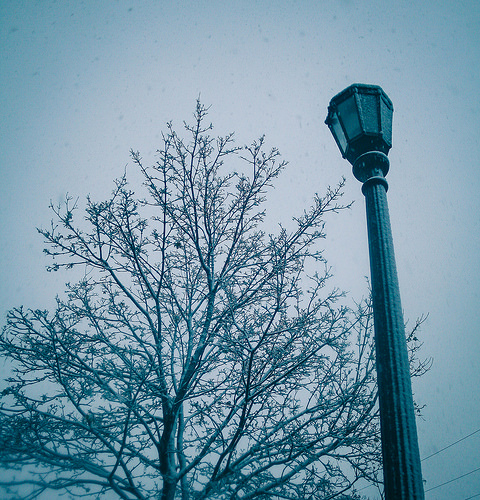<image>
Can you confirm if the street lamp is in front of the tree? Yes. The street lamp is positioned in front of the tree, appearing closer to the camera viewpoint. 